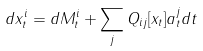<formula> <loc_0><loc_0><loc_500><loc_500>d x _ { t } ^ { i } = d M _ { t } ^ { i } + \sum _ { j } Q _ { i j } [ x _ { t } ] a _ { t } ^ { j } d t</formula> 